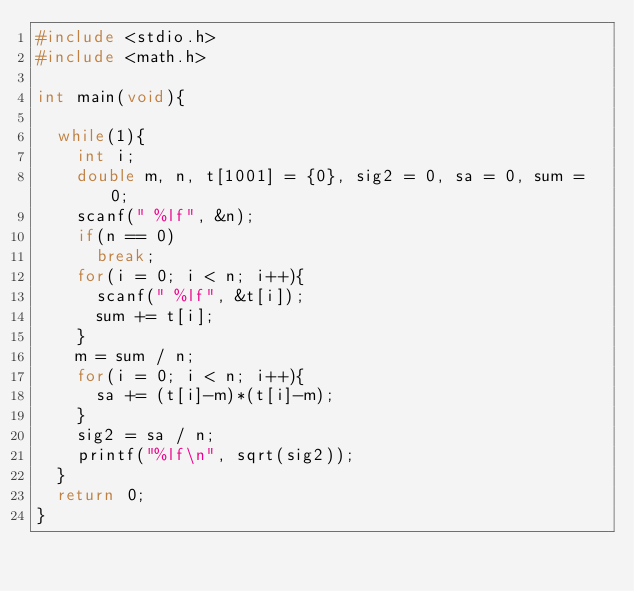<code> <loc_0><loc_0><loc_500><loc_500><_C_>#include <stdio.h>
#include <math.h>

int main(void){

  while(1){
    int i;
    double m, n, t[1001] = {0}, sig2 = 0, sa = 0, sum = 0;
    scanf(" %lf", &n);
    if(n == 0)
      break;
    for(i = 0; i < n; i++){
      scanf(" %lf", &t[i]);
      sum += t[i];
    }
    m = sum / n;
    for(i = 0; i < n; i++){
      sa += (t[i]-m)*(t[i]-m);
    }
    sig2 = sa / n;
    printf("%lf\n", sqrt(sig2));
  }  
  return 0;
}</code> 